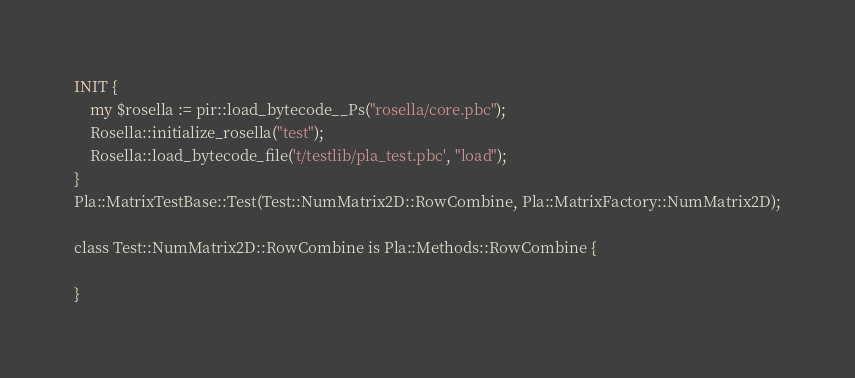Convert code to text. <code><loc_0><loc_0><loc_500><loc_500><_Perl_>INIT {
    my $rosella := pir::load_bytecode__Ps("rosella/core.pbc");
    Rosella::initialize_rosella("test");
    Rosella::load_bytecode_file('t/testlib/pla_test.pbc', "load");
}
Pla::MatrixTestBase::Test(Test::NumMatrix2D::RowCombine, Pla::MatrixFactory::NumMatrix2D);

class Test::NumMatrix2D::RowCombine is Pla::Methods::RowCombine {

}
</code> 